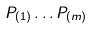<formula> <loc_0><loc_0><loc_500><loc_500>P _ { ( 1 ) } \dots P _ { ( m ) }</formula> 